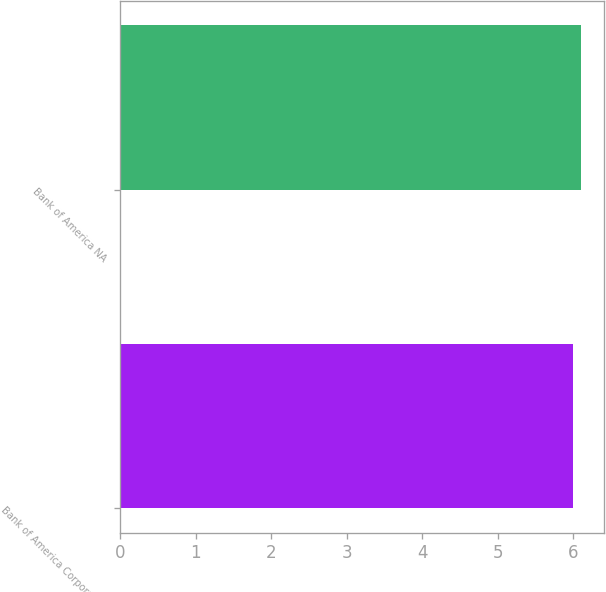<chart> <loc_0><loc_0><loc_500><loc_500><bar_chart><fcel>Bank of America Corporation<fcel>Bank of America NA<nl><fcel>6<fcel>6.1<nl></chart> 